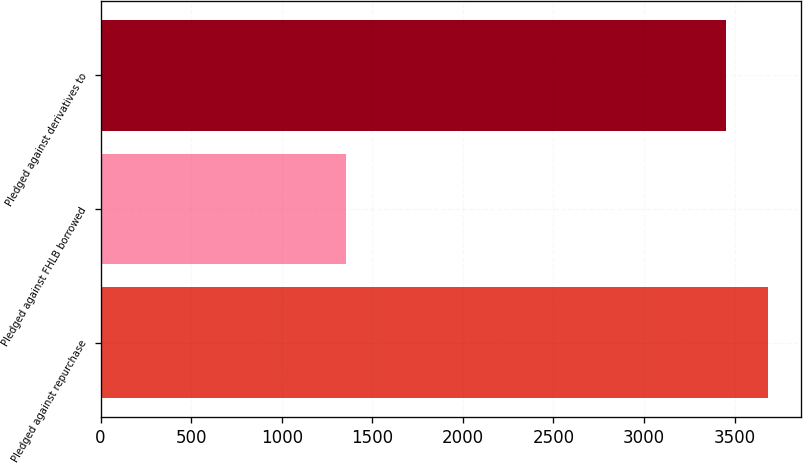Convert chart. <chart><loc_0><loc_0><loc_500><loc_500><bar_chart><fcel>Pledged against repurchase<fcel>Pledged against FHLB borrowed<fcel>Pledged against derivatives to<nl><fcel>3682.5<fcel>1355<fcel>3453<nl></chart> 